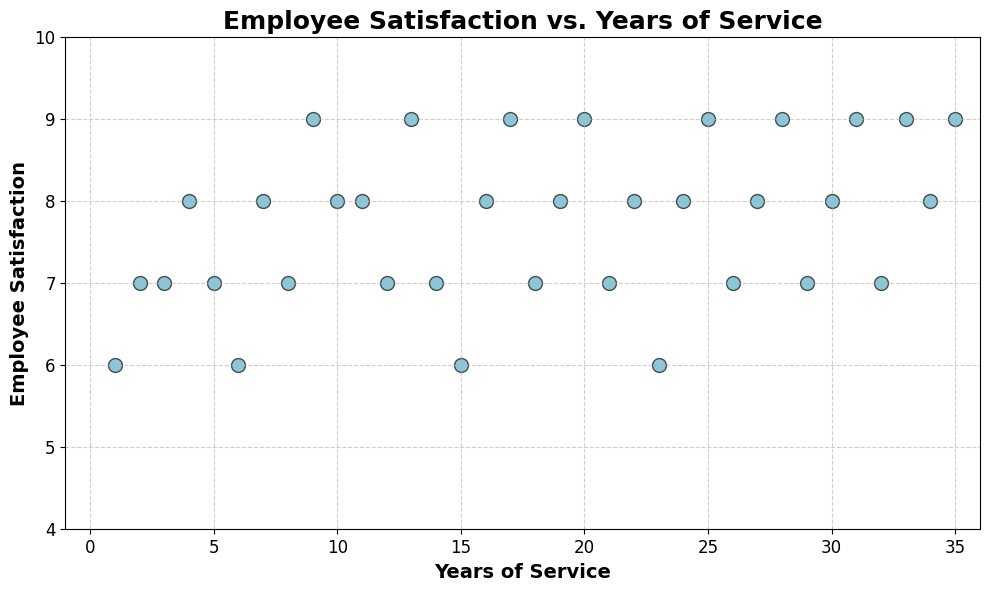What's the overall trend in the relationship between Years of Service and Employee Satisfaction? As the Years of Service increase, Employee Satisfaction generally shows an increasing trend. Initially, there is some fluctuation, but a general upward trend is observable, especially for employees with higher years of service.
Answer: Increasing What is the Employee Satisfaction level for someone with 10 years of service? Locate the data point on the scatter plot corresponding to 10 years of service. The Employee Satisfaction value for this point is 8.
Answer: 8 Which years have the highest Employee Satisfaction level? The highest Employee Satisfaction value on the scatter plot is 9. By looking at the plot, employees with 9, 13, 17, 20, 25, 28, 31, and 35 years of service have this level of satisfaction.
Answer: 9, 13, 17, 20, 25, 28, 31, 35 Between 5 and 10 years of service, which year has the highest Employee Satisfaction level? Observe the relevant data points for these years: 5, 6, 7, 8, 9, 10 on the scatter plot. The highest Employee Satisfaction value is 9, which occurs at 9 years of service.
Answer: 9 What's the average Employee Satisfaction for employees with 15, 20, 25, and 30 years of service? Find the values for each of these years on the scatter plot (15: 6, 20: 9, 25: 9, 30: 8). The average is calculated as (6 + 9 + 9 + 8) / 4 = 32 / 4 = 8.
Answer: 8 For employees with less than 5 years of service, which year has the lowest Employee Satisfaction? By observing the points for 1, 2, 3, and 4 years, the lowest Employee Satisfaction is 6, which occurs at 1 year of service.
Answer: 1 Which two years have the same Employee Satisfaction level of 7 but differ most in Years of Service? Identify points where Employee Satisfaction is 7. These years are 2, 3, 5, 8, 12, 14, 18, 21, 26, 29, 32. The largest difference is between 2 years and 32 years, with a difference of 30 years.
Answer: 2, 32 What is the range of Employee Satisfaction values across all data points? Find the minimum and maximum Employee Satisfaction values. The minimum is 6, and the maximum is 9. The range is 9 - 6 = 3.
Answer: 3 Is there any year of service where the Employee Satisfaction is 8 consistently? By checking the scatter plot, it's clear that years 4, 10, 11, 16, 19, 22, 24, 27, and 34 all have an Employee Satisfaction of 8, but not consistently for any single year.
Answer: No If an employee's satisfaction level is 6, which years of service could they have? Points with an Employee Satisfaction of 6 are observed at years 1, 6, 15, and 23.
Answer: 1, 6, 15, 23 